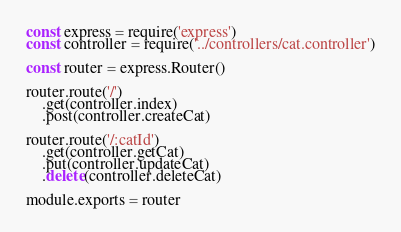<code> <loc_0><loc_0><loc_500><loc_500><_JavaScript_>const express = require('express')
const controller = require('../controllers/cat.controller')

const router = express.Router()

router.route('/')
	.get(controller.index)
	.post(controller.createCat)

router.route('/:catId')
	.get(controller.getCat)
	.put(controller.updateCat)
	.delete(controller.deleteCat)

module.exports = router</code> 